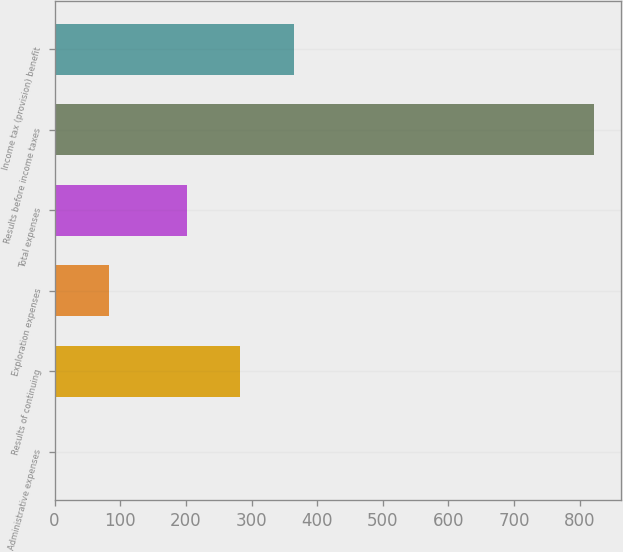<chart> <loc_0><loc_0><loc_500><loc_500><bar_chart><fcel>Administrative expenses<fcel>Results of continuing<fcel>Exploration expenses<fcel>Total expenses<fcel>Results before income taxes<fcel>Income tax (provision) benefit<nl><fcel>1<fcel>283.1<fcel>83.1<fcel>201<fcel>822<fcel>365.2<nl></chart> 